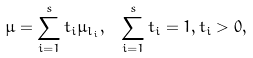<formula> <loc_0><loc_0><loc_500><loc_500>\mu = \sum _ { i = 1 } ^ { s } t _ { i } \mu _ { l _ { i } } , \text { } \sum _ { i = 1 } ^ { s } t _ { i } = 1 , t _ { i } > 0 ,</formula> 